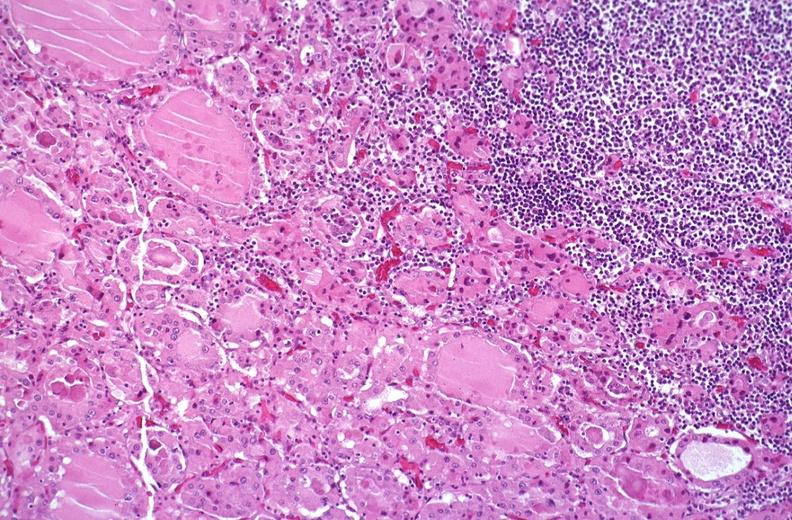s leiomyosarcoma present?
Answer the question using a single word or phrase. No 